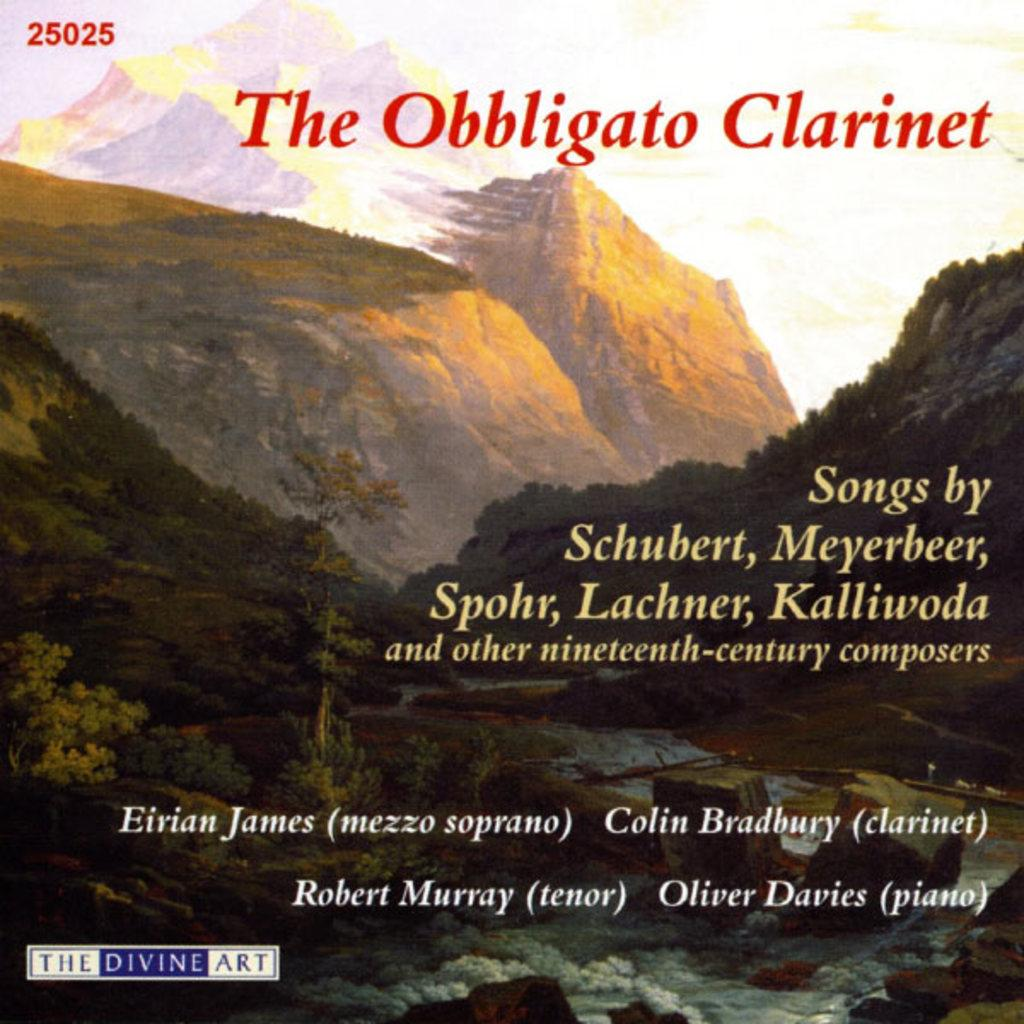<image>
Summarize the visual content of the image. a cd cover that says 'the divine art' on it 